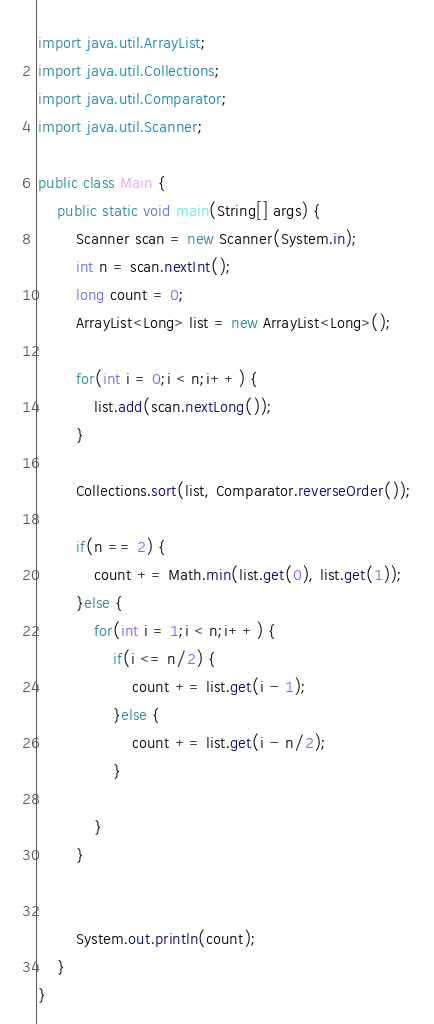Convert code to text. <code><loc_0><loc_0><loc_500><loc_500><_Java_>import java.util.ArrayList;
import java.util.Collections;
import java.util.Comparator;
import java.util.Scanner;

public class Main {
	public static void main(String[] args) {
		Scanner scan = new Scanner(System.in);
		int n = scan.nextInt();
		long count = 0;
		ArrayList<Long> list = new ArrayList<Long>();

		for(int i = 0;i < n;i++) {
			list.add(scan.nextLong());
		}

		Collections.sort(list, Comparator.reverseOrder());

		if(n == 2) {
			count += Math.min(list.get(0), list.get(1));
		}else {
			for(int i = 1;i < n;i++) {
				if(i <= n/2) {
					count += list.get(i - 1);
				}else {
					count += list.get(i - n/2);
				}

			}
		}


		System.out.println(count);
	}
}
</code> 